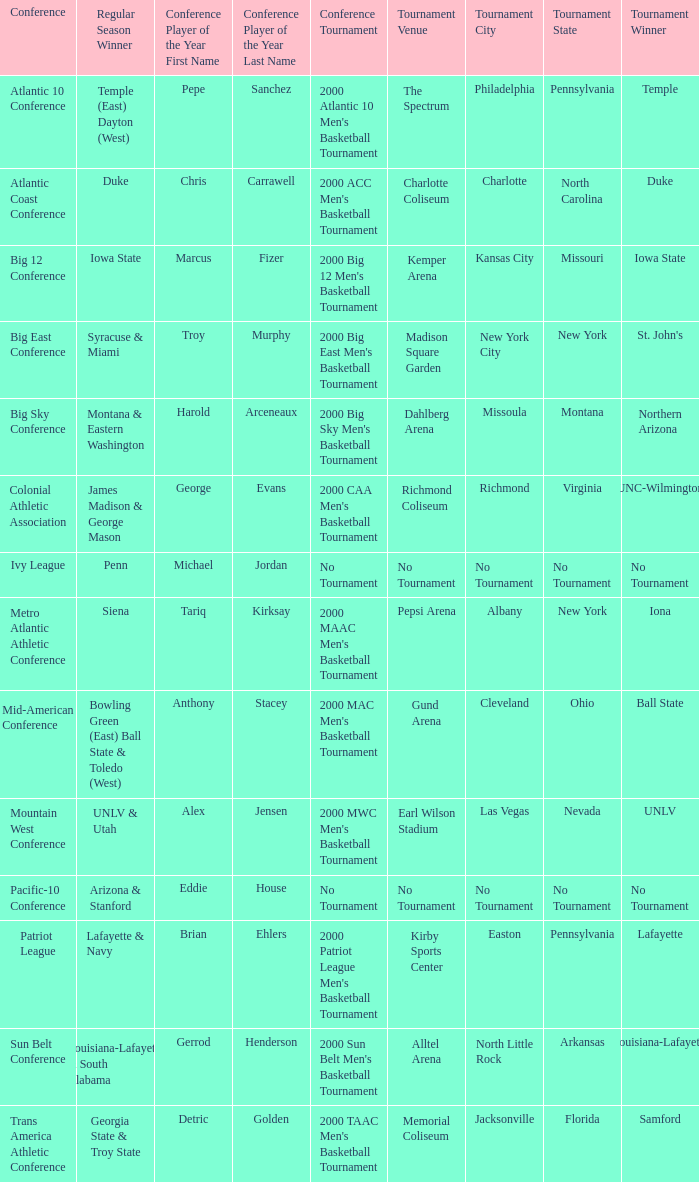Who is the winner of the ivy league conference's regular season? Penn. 